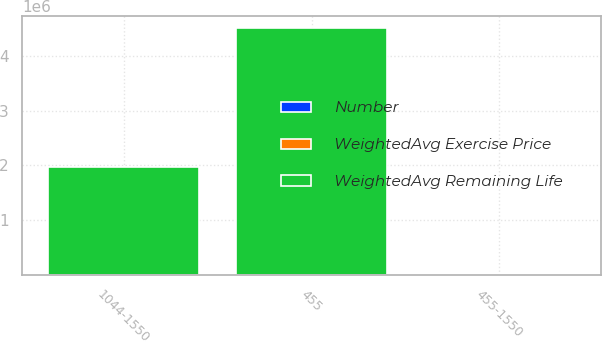Convert chart. <chart><loc_0><loc_0><loc_500><loc_500><stacked_bar_chart><ecel><fcel>455<fcel>1044-1550<fcel>455-1550<nl><fcel>WeightedAvg Remaining Life<fcel>4.50562e+06<fcel>1.97282e+06<fcel>8.265<nl><fcel>Number<fcel>7.5<fcel>8.67<fcel>7.86<nl><fcel>WeightedAvg Exercise Price<fcel>4.55<fcel>13.62<fcel>7.31<nl></chart> 